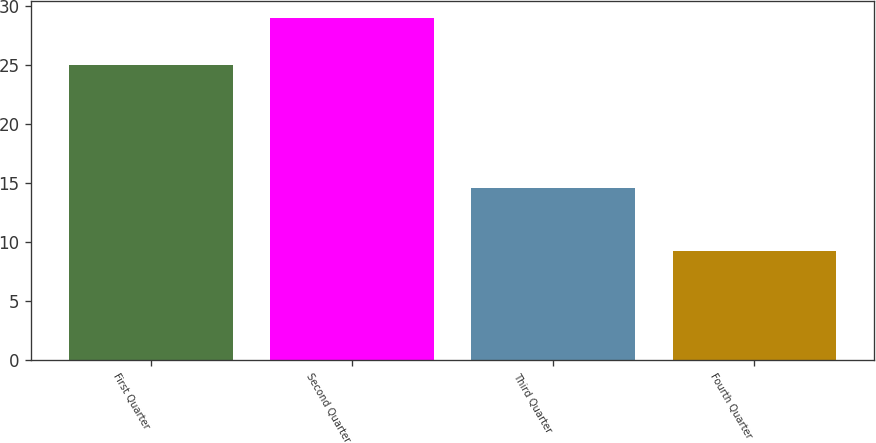Convert chart. <chart><loc_0><loc_0><loc_500><loc_500><bar_chart><fcel>First Quarter<fcel>Second Quarter<fcel>Third Quarter<fcel>Fourth Quarter<nl><fcel>25.06<fcel>29.02<fcel>14.6<fcel>9.25<nl></chart> 